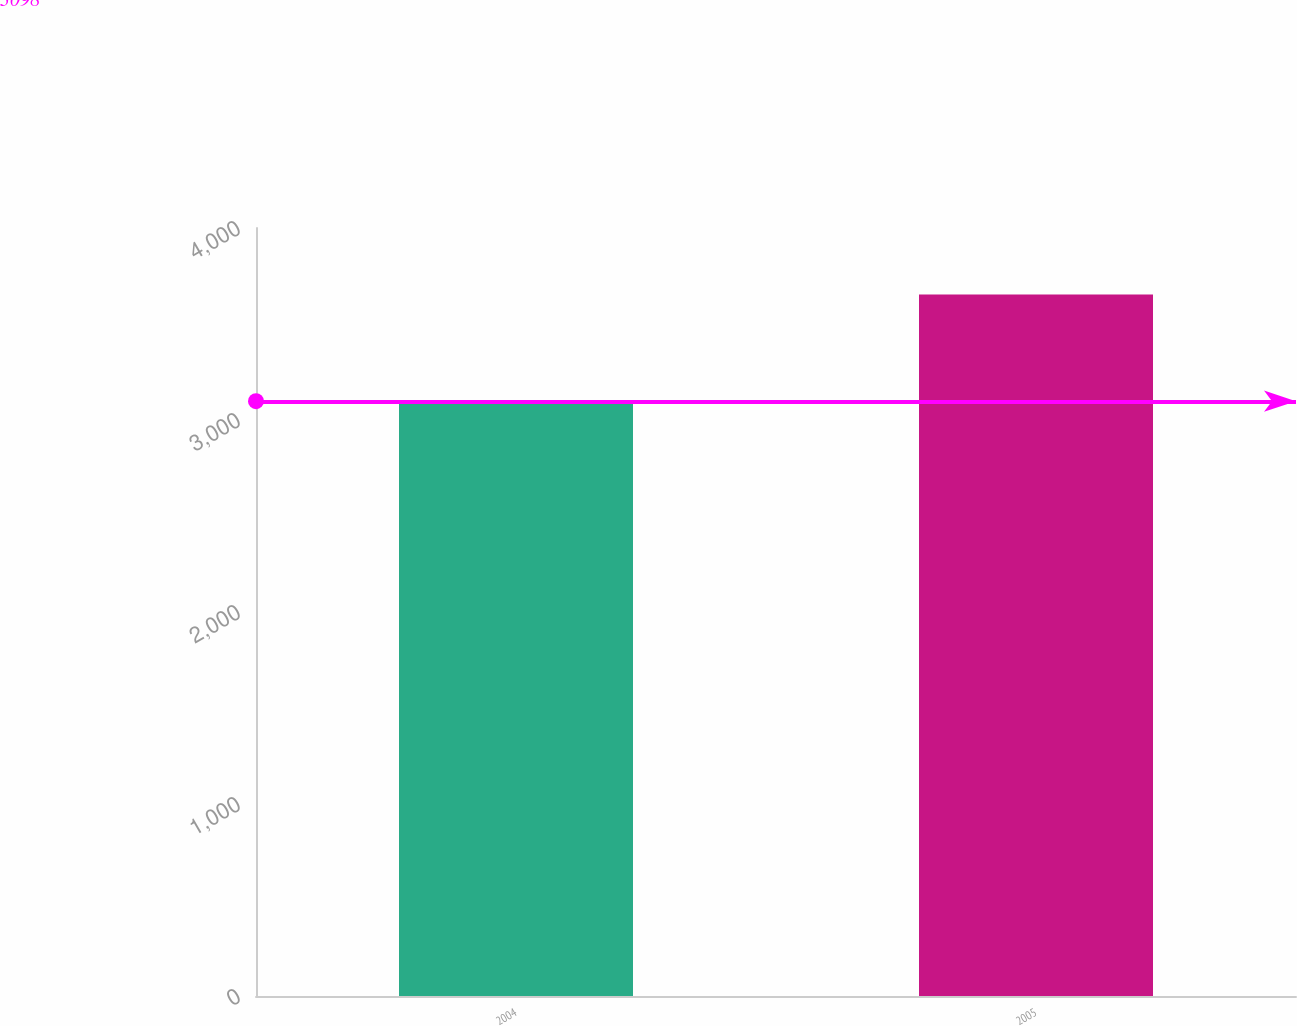<chart> <loc_0><loc_0><loc_500><loc_500><bar_chart><fcel>2004<fcel>2005<nl><fcel>3098<fcel>3653<nl></chart> 